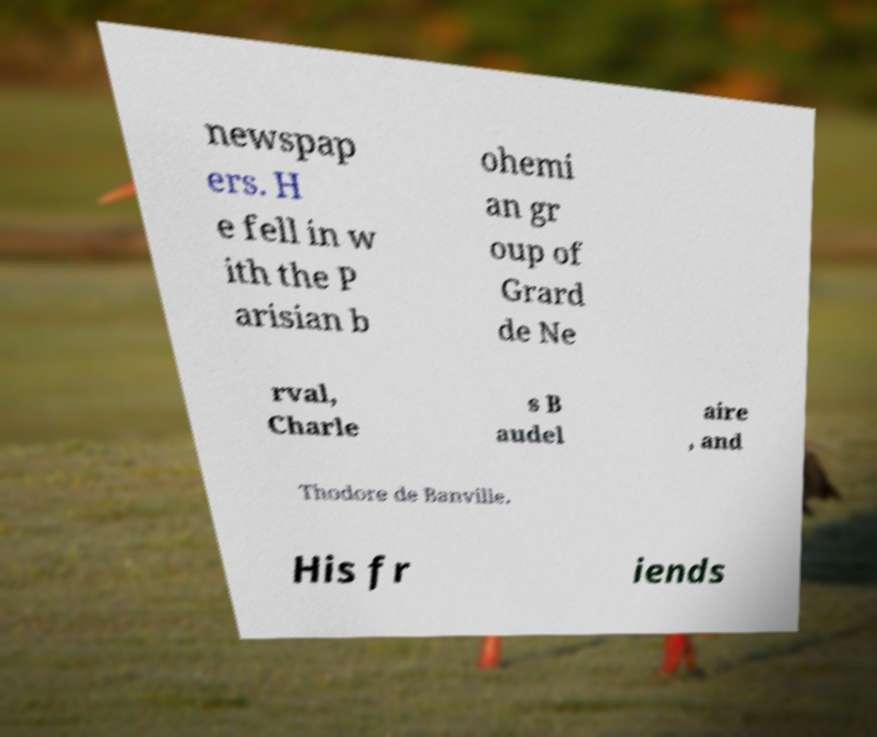Could you assist in decoding the text presented in this image and type it out clearly? newspap ers. H e fell in w ith the P arisian b ohemi an gr oup of Grard de Ne rval, Charle s B audel aire , and Thodore de Banville. His fr iends 